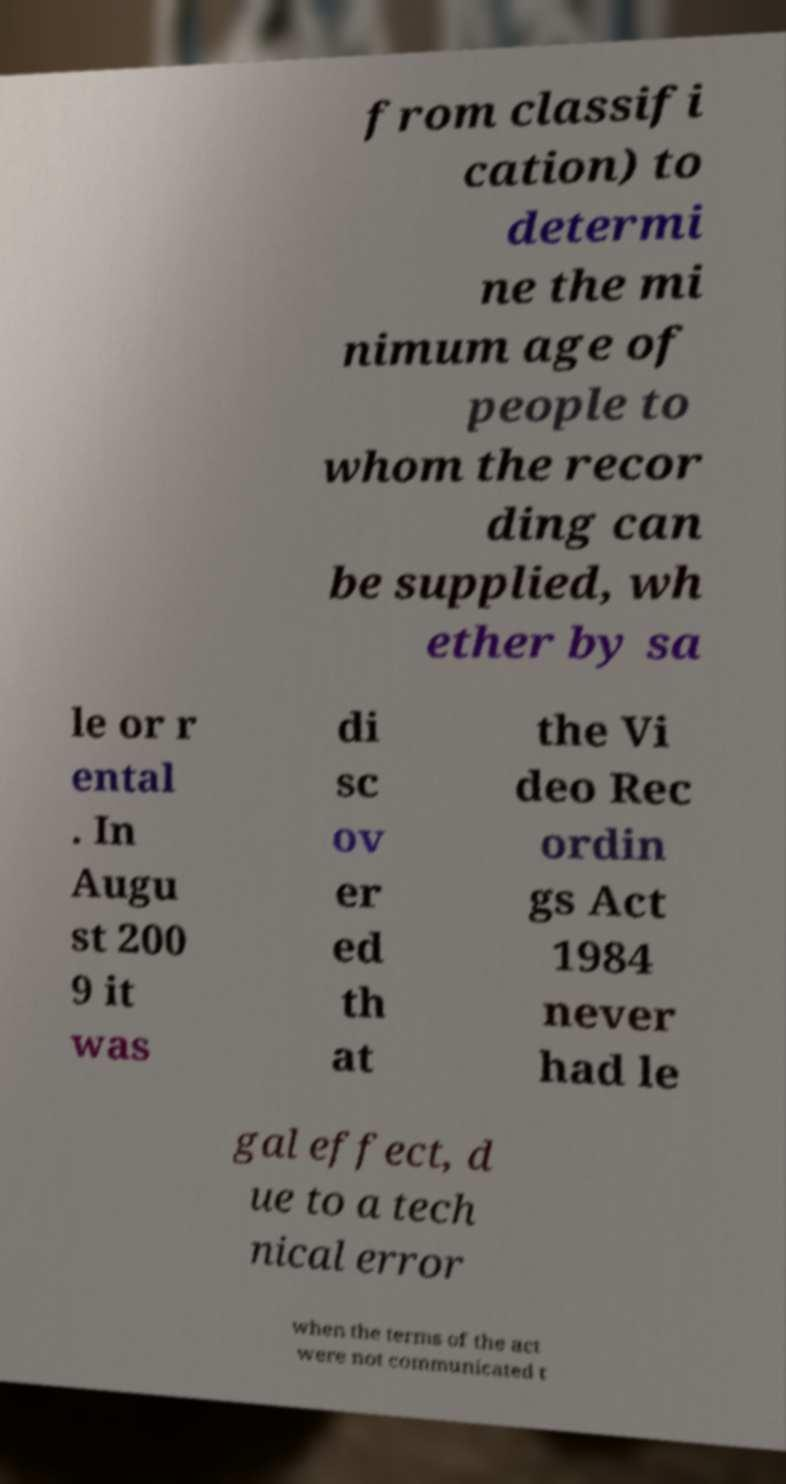I need the written content from this picture converted into text. Can you do that? from classifi cation) to determi ne the mi nimum age of people to whom the recor ding can be supplied, wh ether by sa le or r ental . In Augu st 200 9 it was di sc ov er ed th at the Vi deo Rec ordin gs Act 1984 never had le gal effect, d ue to a tech nical error when the terms of the act were not communicated t 